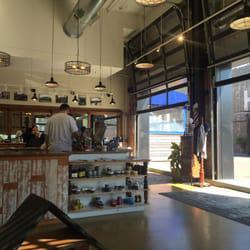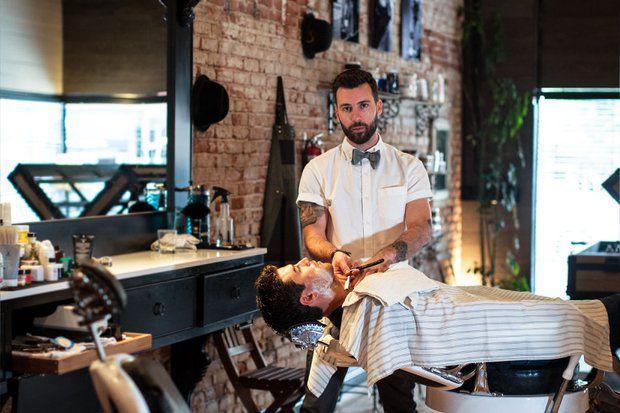The first image is the image on the left, the second image is the image on the right. For the images displayed, is the sentence "A camera-facing man is standing by a camera-facing empty black barber chair with white arms, in one image." factually correct? Answer yes or no. No. The first image is the image on the left, the second image is the image on the right. Examine the images to the left and right. Is the description "In one image a single barber is working with a customer, while a person stands at a store counter in the second image." accurate? Answer yes or no. Yes. 